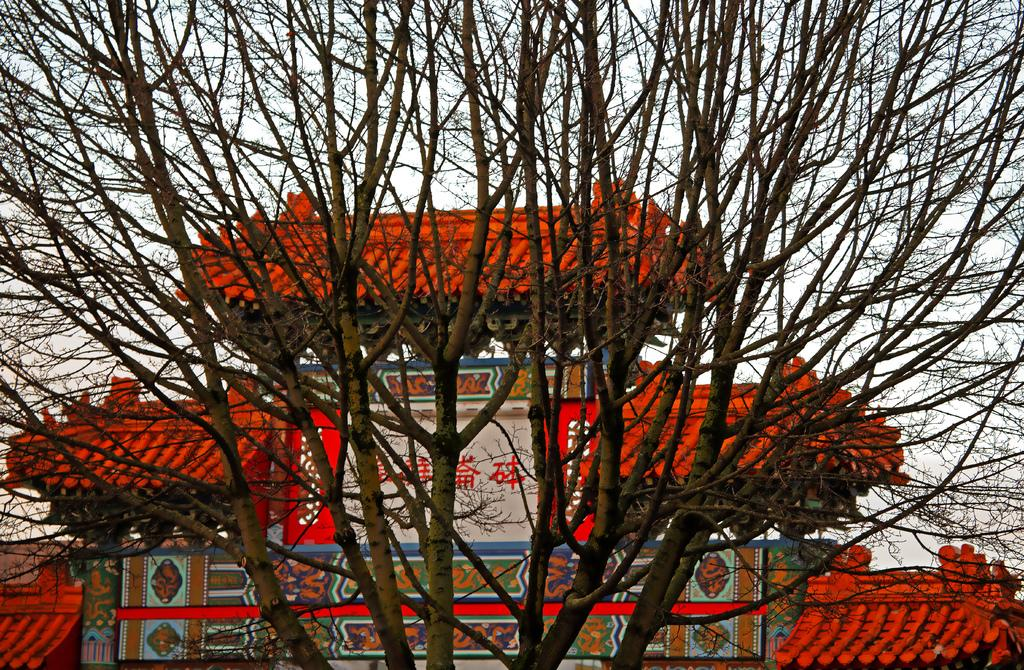What type of structure is present in the image? There is a building in the image. What type of plant is visible in the image? There is a tree with branches and stems in the image. What can be seen in the background of the image? The sky is visible in the background of the image. What song is being played in the background of the image? There is no song playing in the background of the image; it is a still image. What type of property is being sold in the image? There is no property being sold in the image; it only features a building and a tree. 